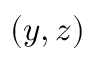<formula> <loc_0><loc_0><loc_500><loc_500>( y , z )</formula> 